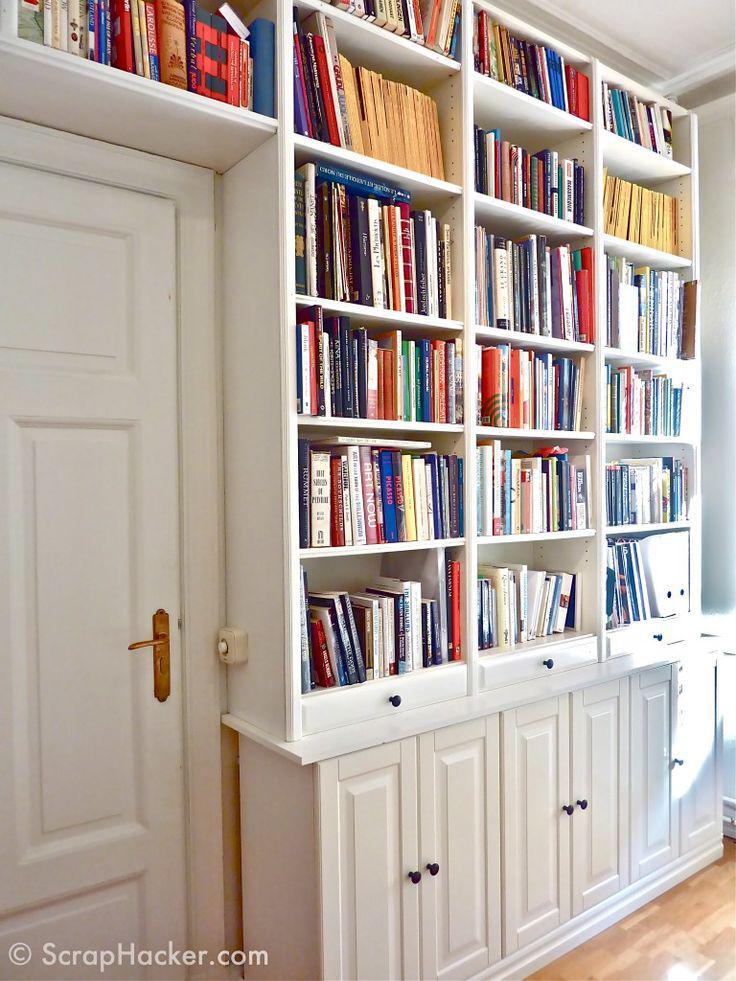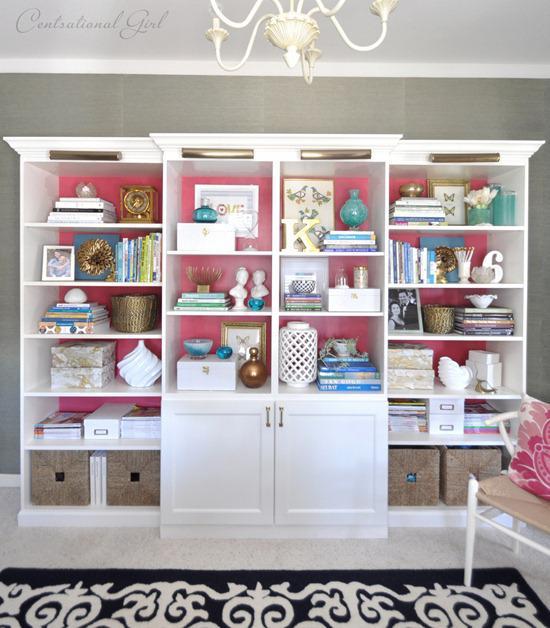The first image is the image on the left, the second image is the image on the right. For the images shown, is this caption "In one image, a floor to ceiling white shelving unit is curved around the corner of a room." true? Answer yes or no. No. 